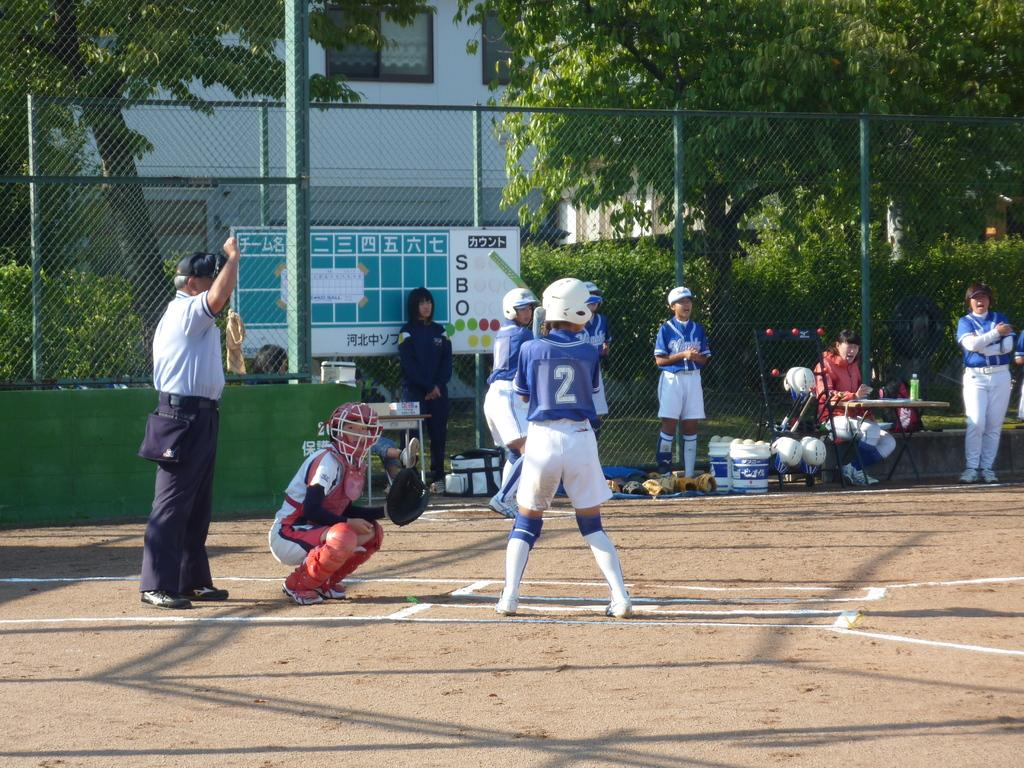<image>
Share a concise interpretation of the image provided. Number 2 wearing a blue jersey is at bat in a game. 